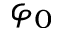<formula> <loc_0><loc_0><loc_500><loc_500>\varphi _ { 0 }</formula> 